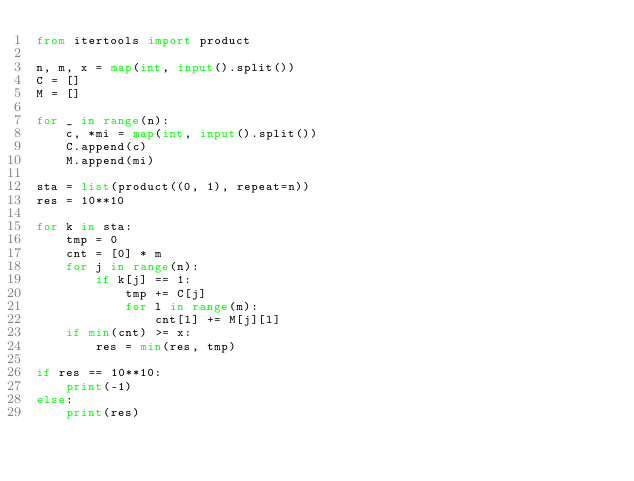<code> <loc_0><loc_0><loc_500><loc_500><_Python_>from itertools import product

n, m, x = map(int, input().split())
C = []
M = []

for _ in range(n):
    c, *mi = map(int, input().split())
    C.append(c)
    M.append(mi)

sta = list(product((0, 1), repeat=n))
res = 10**10

for k in sta:
    tmp = 0
    cnt = [0] * m
    for j in range(n):
        if k[j] == 1:
            tmp += C[j]
            for l in range(m):
                cnt[l] += M[j][l]
    if min(cnt) >= x:
        res = min(res, tmp)

if res == 10**10:
    print(-1)
else:
    print(res)
</code> 